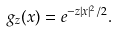Convert formula to latex. <formula><loc_0><loc_0><loc_500><loc_500>g _ { z } ( x ) = e ^ { - z | x | ^ { 2 } / 2 } .</formula> 